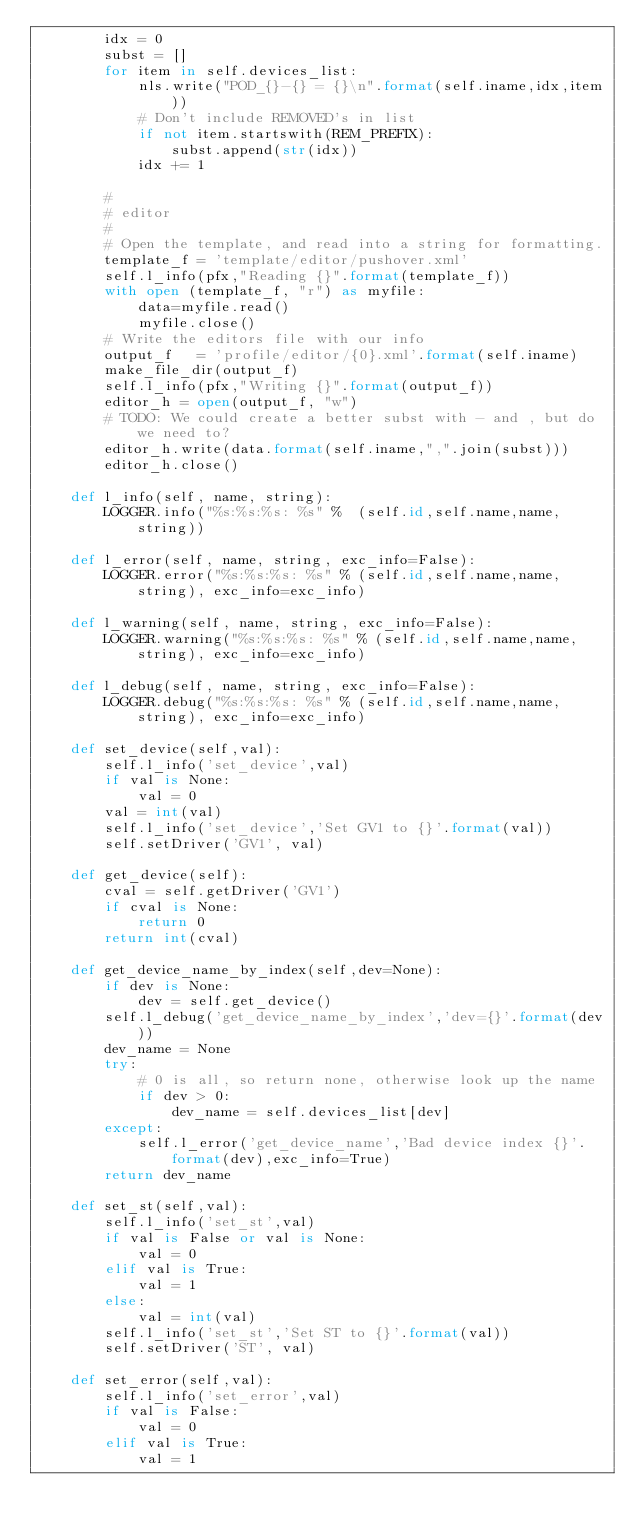Convert code to text. <code><loc_0><loc_0><loc_500><loc_500><_Python_>        idx = 0
        subst = []
        for item in self.devices_list:
            nls.write("POD_{}-{} = {}\n".format(self.iname,idx,item))
            # Don't include REMOVED's in list
            if not item.startswith(REM_PREFIX):
                subst.append(str(idx))
            idx += 1

        #
        # editor
        #
        # Open the template, and read into a string for formatting.
        template_f = 'template/editor/pushover.xml'
        self.l_info(pfx,"Reading {}".format(template_f))
        with open (template_f, "r") as myfile:
            data=myfile.read()
            myfile.close()
        # Write the editors file with our info
        output_f   = 'profile/editor/{0}.xml'.format(self.iname)
        make_file_dir(output_f)
        self.l_info(pfx,"Writing {}".format(output_f))
        editor_h = open(output_f, "w")
        # TODO: We could create a better subst with - and , but do we need to?
        editor_h.write(data.format(self.iname,",".join(subst)))
        editor_h.close()

    def l_info(self, name, string):
        LOGGER.info("%s:%s:%s: %s" %  (self.id,self.name,name,string))

    def l_error(self, name, string, exc_info=False):
        LOGGER.error("%s:%s:%s: %s" % (self.id,self.name,name,string), exc_info=exc_info)

    def l_warning(self, name, string, exc_info=False):
        LOGGER.warning("%s:%s:%s: %s" % (self.id,self.name,name,string), exc_info=exc_info)

    def l_debug(self, name, string, exc_info=False):
        LOGGER.debug("%s:%s:%s: %s" % (self.id,self.name,name,string), exc_info=exc_info)

    def set_device(self,val):
        self.l_info('set_device',val)
        if val is None:
            val = 0
        val = int(val)
        self.l_info('set_device','Set GV1 to {}'.format(val))
        self.setDriver('GV1', val)

    def get_device(self):
        cval = self.getDriver('GV1')
        if cval is None:
            return 0
        return int(cval)

    def get_device_name_by_index(self,dev=None):
        if dev is None:
            dev = self.get_device()
        self.l_debug('get_device_name_by_index','dev={}'.format(dev))
        dev_name = None
        try:
            # 0 is all, so return none, otherwise look up the name
            if dev > 0:
                dev_name = self.devices_list[dev]
        except:
            self.l_error('get_device_name','Bad device index {}'.format(dev),exc_info=True)
        return dev_name

    def set_st(self,val):
        self.l_info('set_st',val)
        if val is False or val is None:
            val = 0
        elif val is True:
            val = 1
        else:
            val = int(val)
        self.l_info('set_st','Set ST to {}'.format(val))
        self.setDriver('ST', val)

    def set_error(self,val):
        self.l_info('set_error',val)
        if val is False:
            val = 0
        elif val is True:
            val = 1</code> 